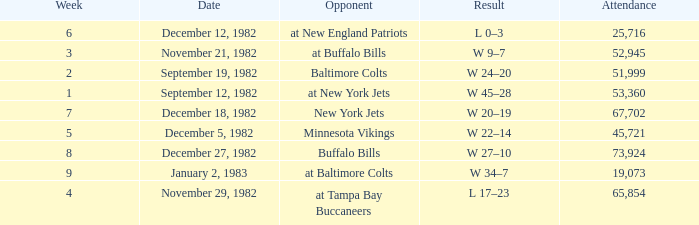What week was the game on September 12, 1982 with an attendance greater than 51,999? 1.0. 